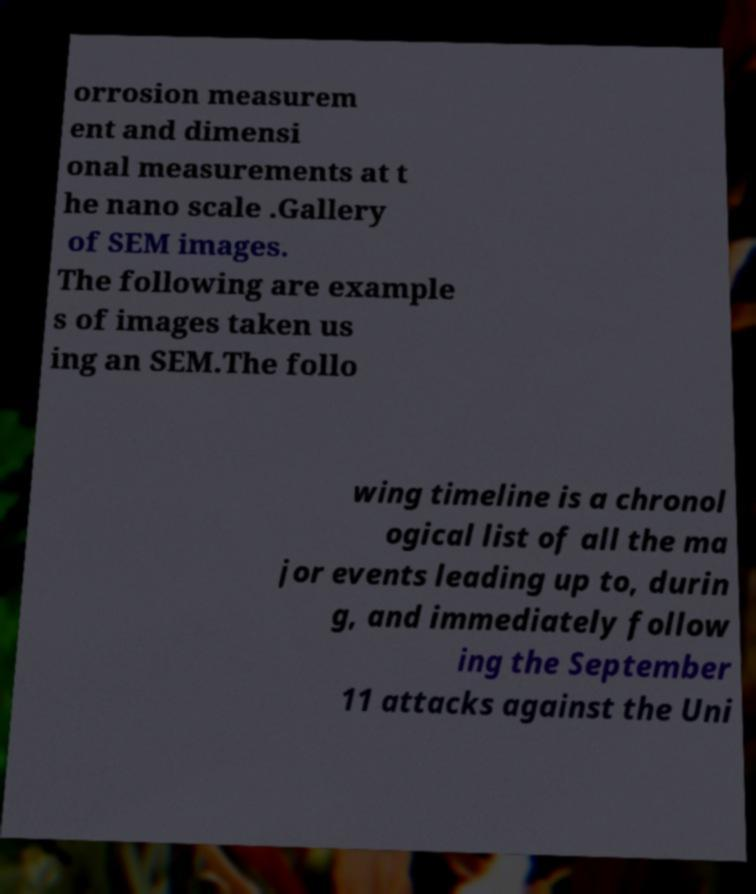Could you assist in decoding the text presented in this image and type it out clearly? orrosion measurem ent and dimensi onal measurements at t he nano scale .Gallery of SEM images. The following are example s of images taken us ing an SEM.The follo wing timeline is a chronol ogical list of all the ma jor events leading up to, durin g, and immediately follow ing the September 11 attacks against the Uni 